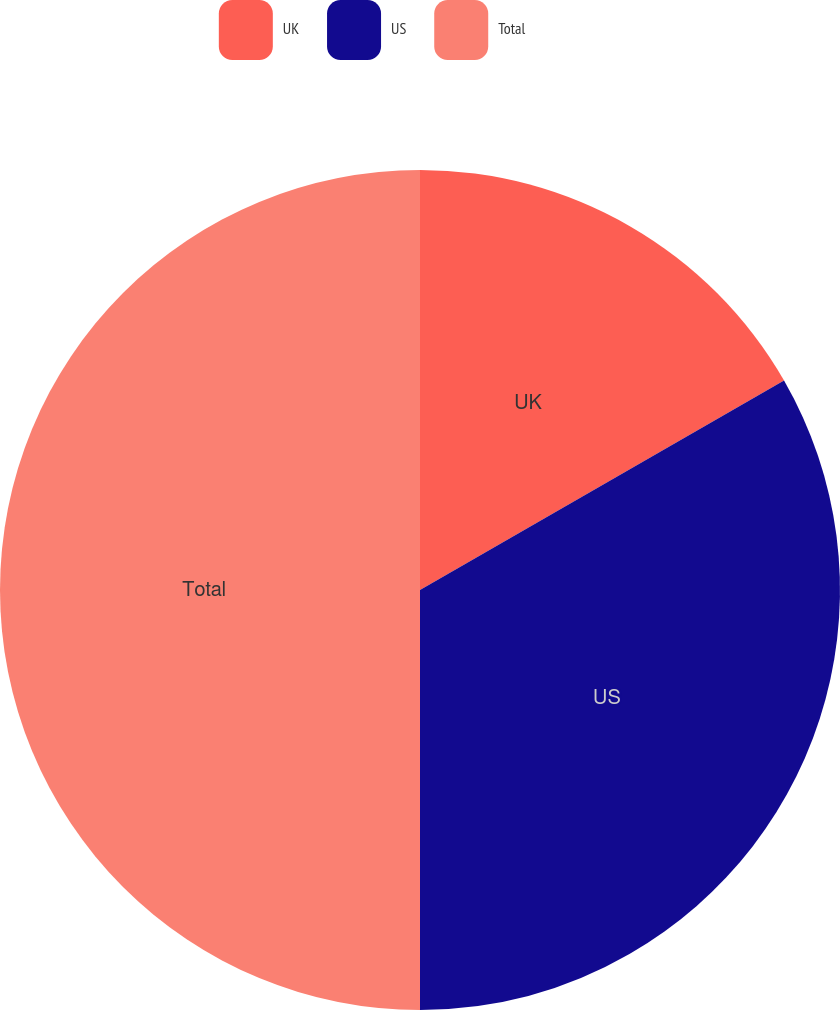<chart> <loc_0><loc_0><loc_500><loc_500><pie_chart><fcel>UK<fcel>US<fcel>Total<nl><fcel>16.69%<fcel>33.31%<fcel>50.0%<nl></chart> 